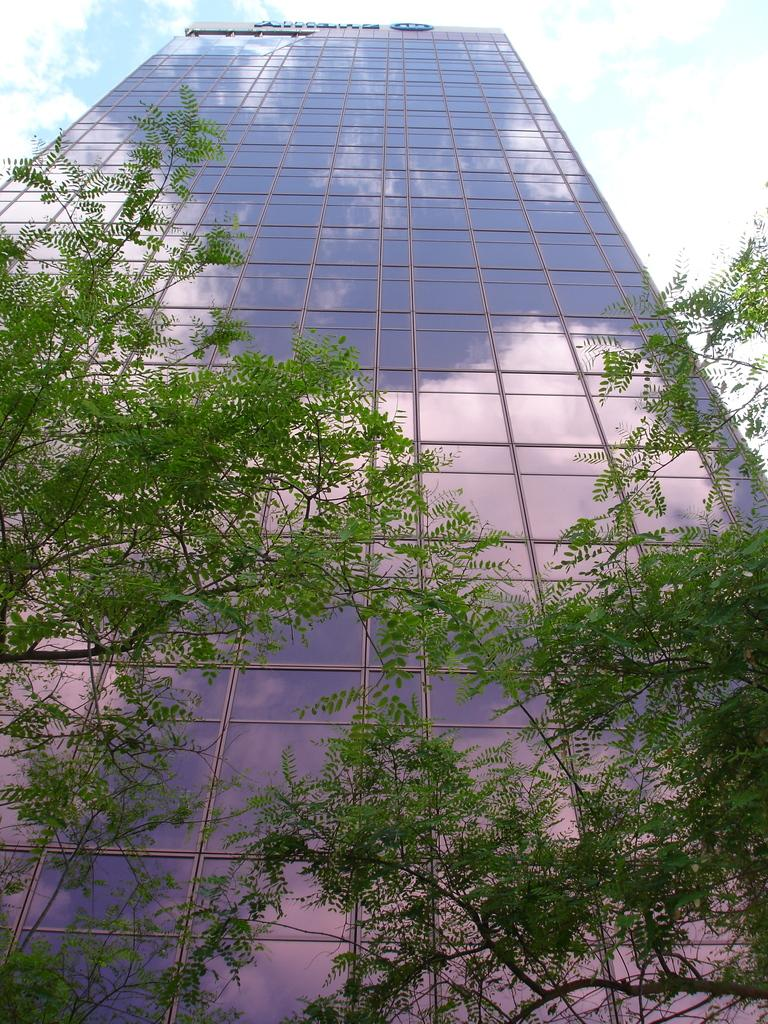What is the possible location from where the image was taken? The image might be taken from outside of a building. What type of vegetation can be seen in the image? There are trees in the image. What structure is visible in the background of the image? There is a building in the background of the image. What part of the natural environment is visible in the image? The sky is visible in the background of the image. What type of insect can be seen flying near the building in the image? There is no insect visible in the image; it only features trees, a building, and the sky. 